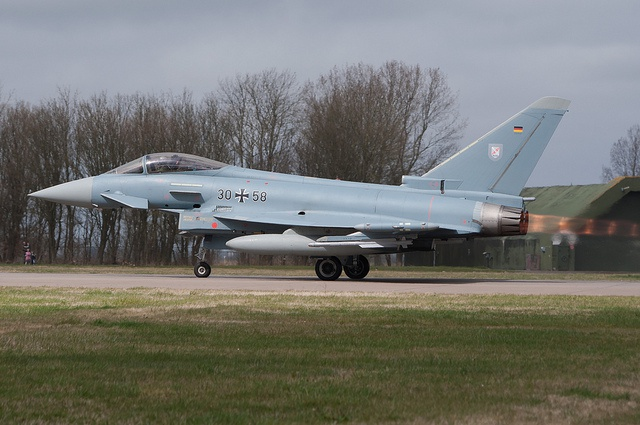Describe the objects in this image and their specific colors. I can see airplane in darkgray, black, and gray tones, people in darkgray, gray, and black tones, people in darkgray, black, and brown tones, and people in darkgray, gray, and black tones in this image. 